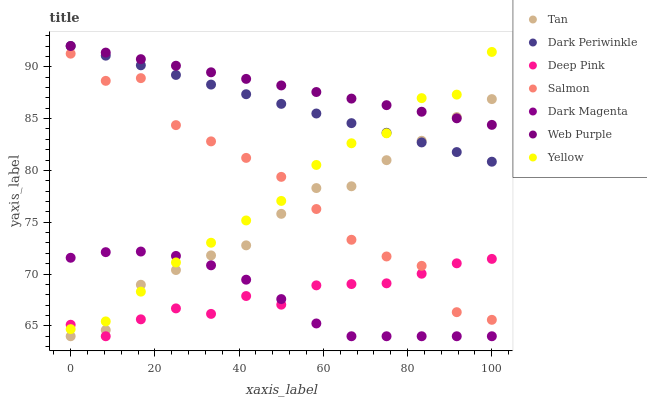Does Dark Magenta have the minimum area under the curve?
Answer yes or no. Yes. Does Web Purple have the maximum area under the curve?
Answer yes or no. Yes. Does Salmon have the minimum area under the curve?
Answer yes or no. No. Does Salmon have the maximum area under the curve?
Answer yes or no. No. Is Web Purple the smoothest?
Answer yes or no. Yes. Is Salmon the roughest?
Answer yes or no. Yes. Is Dark Magenta the smoothest?
Answer yes or no. No. Is Dark Magenta the roughest?
Answer yes or no. No. Does Deep Pink have the lowest value?
Answer yes or no. Yes. Does Salmon have the lowest value?
Answer yes or no. No. Does Dark Periwinkle have the highest value?
Answer yes or no. Yes. Does Dark Magenta have the highest value?
Answer yes or no. No. Is Dark Magenta less than Dark Periwinkle?
Answer yes or no. Yes. Is Salmon greater than Dark Magenta?
Answer yes or no. Yes. Does Salmon intersect Yellow?
Answer yes or no. Yes. Is Salmon less than Yellow?
Answer yes or no. No. Is Salmon greater than Yellow?
Answer yes or no. No. Does Dark Magenta intersect Dark Periwinkle?
Answer yes or no. No. 